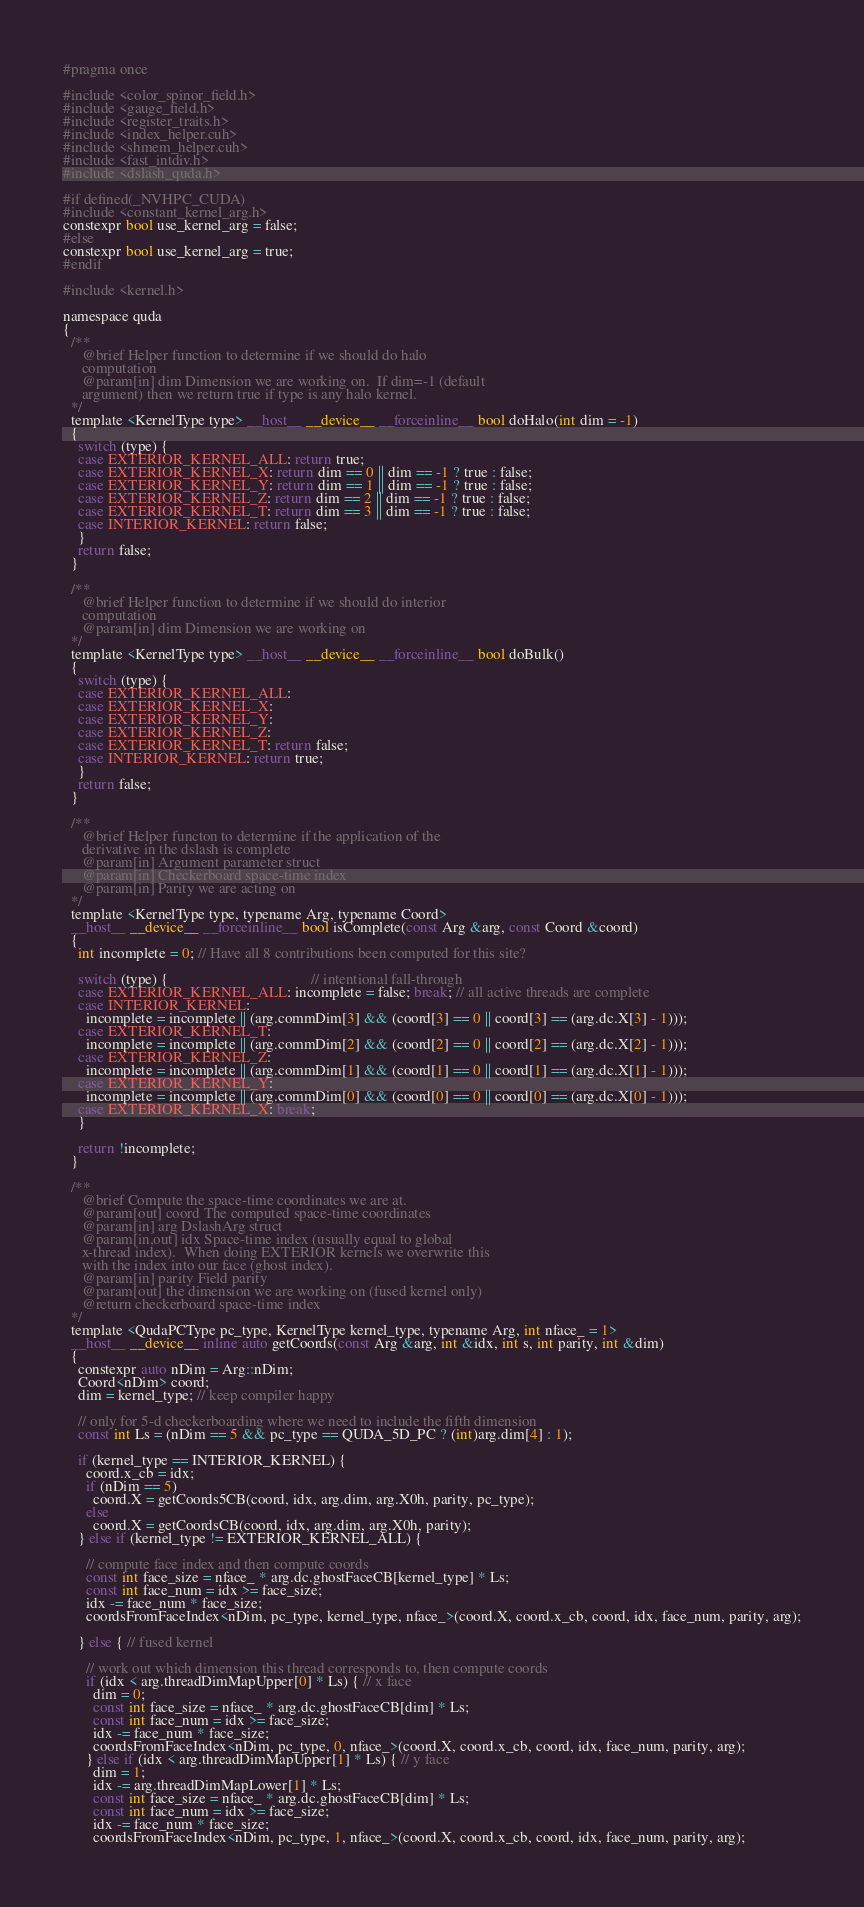<code> <loc_0><loc_0><loc_500><loc_500><_Cuda_>#pragma once

#include <color_spinor_field.h>
#include <gauge_field.h>
#include <register_traits.h>
#include <index_helper.cuh>
#include <shmem_helper.cuh>
#include <fast_intdiv.h>
#include <dslash_quda.h>

#if defined(_NVHPC_CUDA)
#include <constant_kernel_arg.h>
constexpr bool use_kernel_arg = false;
#else
constexpr bool use_kernel_arg = true;
#endif

#include <kernel.h>

namespace quda
{
  /**
     @brief Helper function to determine if we should do halo
     computation
     @param[in] dim Dimension we are working on.  If dim=-1 (default
     argument) then we return true if type is any halo kernel.
  */
  template <KernelType type> __host__ __device__ __forceinline__ bool doHalo(int dim = -1)
  {
    switch (type) {
    case EXTERIOR_KERNEL_ALL: return true;
    case EXTERIOR_KERNEL_X: return dim == 0 || dim == -1 ? true : false;
    case EXTERIOR_KERNEL_Y: return dim == 1 || dim == -1 ? true : false;
    case EXTERIOR_KERNEL_Z: return dim == 2 || dim == -1 ? true : false;
    case EXTERIOR_KERNEL_T: return dim == 3 || dim == -1 ? true : false;
    case INTERIOR_KERNEL: return false;
    }
    return false;
  }

  /**
     @brief Helper function to determine if we should do interior
     computation
     @param[in] dim Dimension we are working on
  */
  template <KernelType type> __host__ __device__ __forceinline__ bool doBulk()
  {
    switch (type) {
    case EXTERIOR_KERNEL_ALL:
    case EXTERIOR_KERNEL_X:
    case EXTERIOR_KERNEL_Y:
    case EXTERIOR_KERNEL_Z:
    case EXTERIOR_KERNEL_T: return false;
    case INTERIOR_KERNEL: return true;
    }
    return false;
  }

  /**
     @brief Helper functon to determine if the application of the
     derivative in the dslash is complete
     @param[in] Argument parameter struct
     @param[in] Checkerboard space-time index
     @param[in] Parity we are acting on
  */
  template <KernelType type, typename Arg, typename Coord>
  __host__ __device__ __forceinline__ bool isComplete(const Arg &arg, const Coord &coord)
  {
    int incomplete = 0; // Have all 8 contributions been computed for this site?

    switch (type) {                                      // intentional fall-through
    case EXTERIOR_KERNEL_ALL: incomplete = false; break; // all active threads are complete
    case INTERIOR_KERNEL:
      incomplete = incomplete || (arg.commDim[3] && (coord[3] == 0 || coord[3] == (arg.dc.X[3] - 1)));
    case EXTERIOR_KERNEL_T:
      incomplete = incomplete || (arg.commDim[2] && (coord[2] == 0 || coord[2] == (arg.dc.X[2] - 1)));
    case EXTERIOR_KERNEL_Z:
      incomplete = incomplete || (arg.commDim[1] && (coord[1] == 0 || coord[1] == (arg.dc.X[1] - 1)));
    case EXTERIOR_KERNEL_Y:
      incomplete = incomplete || (arg.commDim[0] && (coord[0] == 0 || coord[0] == (arg.dc.X[0] - 1)));
    case EXTERIOR_KERNEL_X: break;
    }

    return !incomplete;
  }

  /**
     @brief Compute the space-time coordinates we are at.
     @param[out] coord The computed space-time coordinates
     @param[in] arg DslashArg struct
     @param[in,out] idx Space-time index (usually equal to global
     x-thread index).  When doing EXTERIOR kernels we overwrite this
     with the index into our face (ghost index).
     @param[in] parity Field parity
     @param[out] the dimension we are working on (fused kernel only)
     @return checkerboard space-time index
  */
  template <QudaPCType pc_type, KernelType kernel_type, typename Arg, int nface_ = 1>
  __host__ __device__ inline auto getCoords(const Arg &arg, int &idx, int s, int parity, int &dim)
  {
    constexpr auto nDim = Arg::nDim;
    Coord<nDim> coord;
    dim = kernel_type; // keep compiler happy

    // only for 5-d checkerboarding where we need to include the fifth dimension
    const int Ls = (nDim == 5 && pc_type == QUDA_5D_PC ? (int)arg.dim[4] : 1);

    if (kernel_type == INTERIOR_KERNEL) {
      coord.x_cb = idx;
      if (nDim == 5)
        coord.X = getCoords5CB(coord, idx, arg.dim, arg.X0h, parity, pc_type);
      else
        coord.X = getCoordsCB(coord, idx, arg.dim, arg.X0h, parity);
    } else if (kernel_type != EXTERIOR_KERNEL_ALL) {

      // compute face index and then compute coords
      const int face_size = nface_ * arg.dc.ghostFaceCB[kernel_type] * Ls;
      const int face_num = idx >= face_size;
      idx -= face_num * face_size;
      coordsFromFaceIndex<nDim, pc_type, kernel_type, nface_>(coord.X, coord.x_cb, coord, idx, face_num, parity, arg);

    } else { // fused kernel

      // work out which dimension this thread corresponds to, then compute coords
      if (idx < arg.threadDimMapUpper[0] * Ls) { // x face
        dim = 0;
        const int face_size = nface_ * arg.dc.ghostFaceCB[dim] * Ls;
        const int face_num = idx >= face_size;
        idx -= face_num * face_size;
        coordsFromFaceIndex<nDim, pc_type, 0, nface_>(coord.X, coord.x_cb, coord, idx, face_num, parity, arg);
      } else if (idx < arg.threadDimMapUpper[1] * Ls) { // y face
        dim = 1;
        idx -= arg.threadDimMapLower[1] * Ls;
        const int face_size = nface_ * arg.dc.ghostFaceCB[dim] * Ls;
        const int face_num = idx >= face_size;
        idx -= face_num * face_size;
        coordsFromFaceIndex<nDim, pc_type, 1, nface_>(coord.X, coord.x_cb, coord, idx, face_num, parity, arg);</code> 